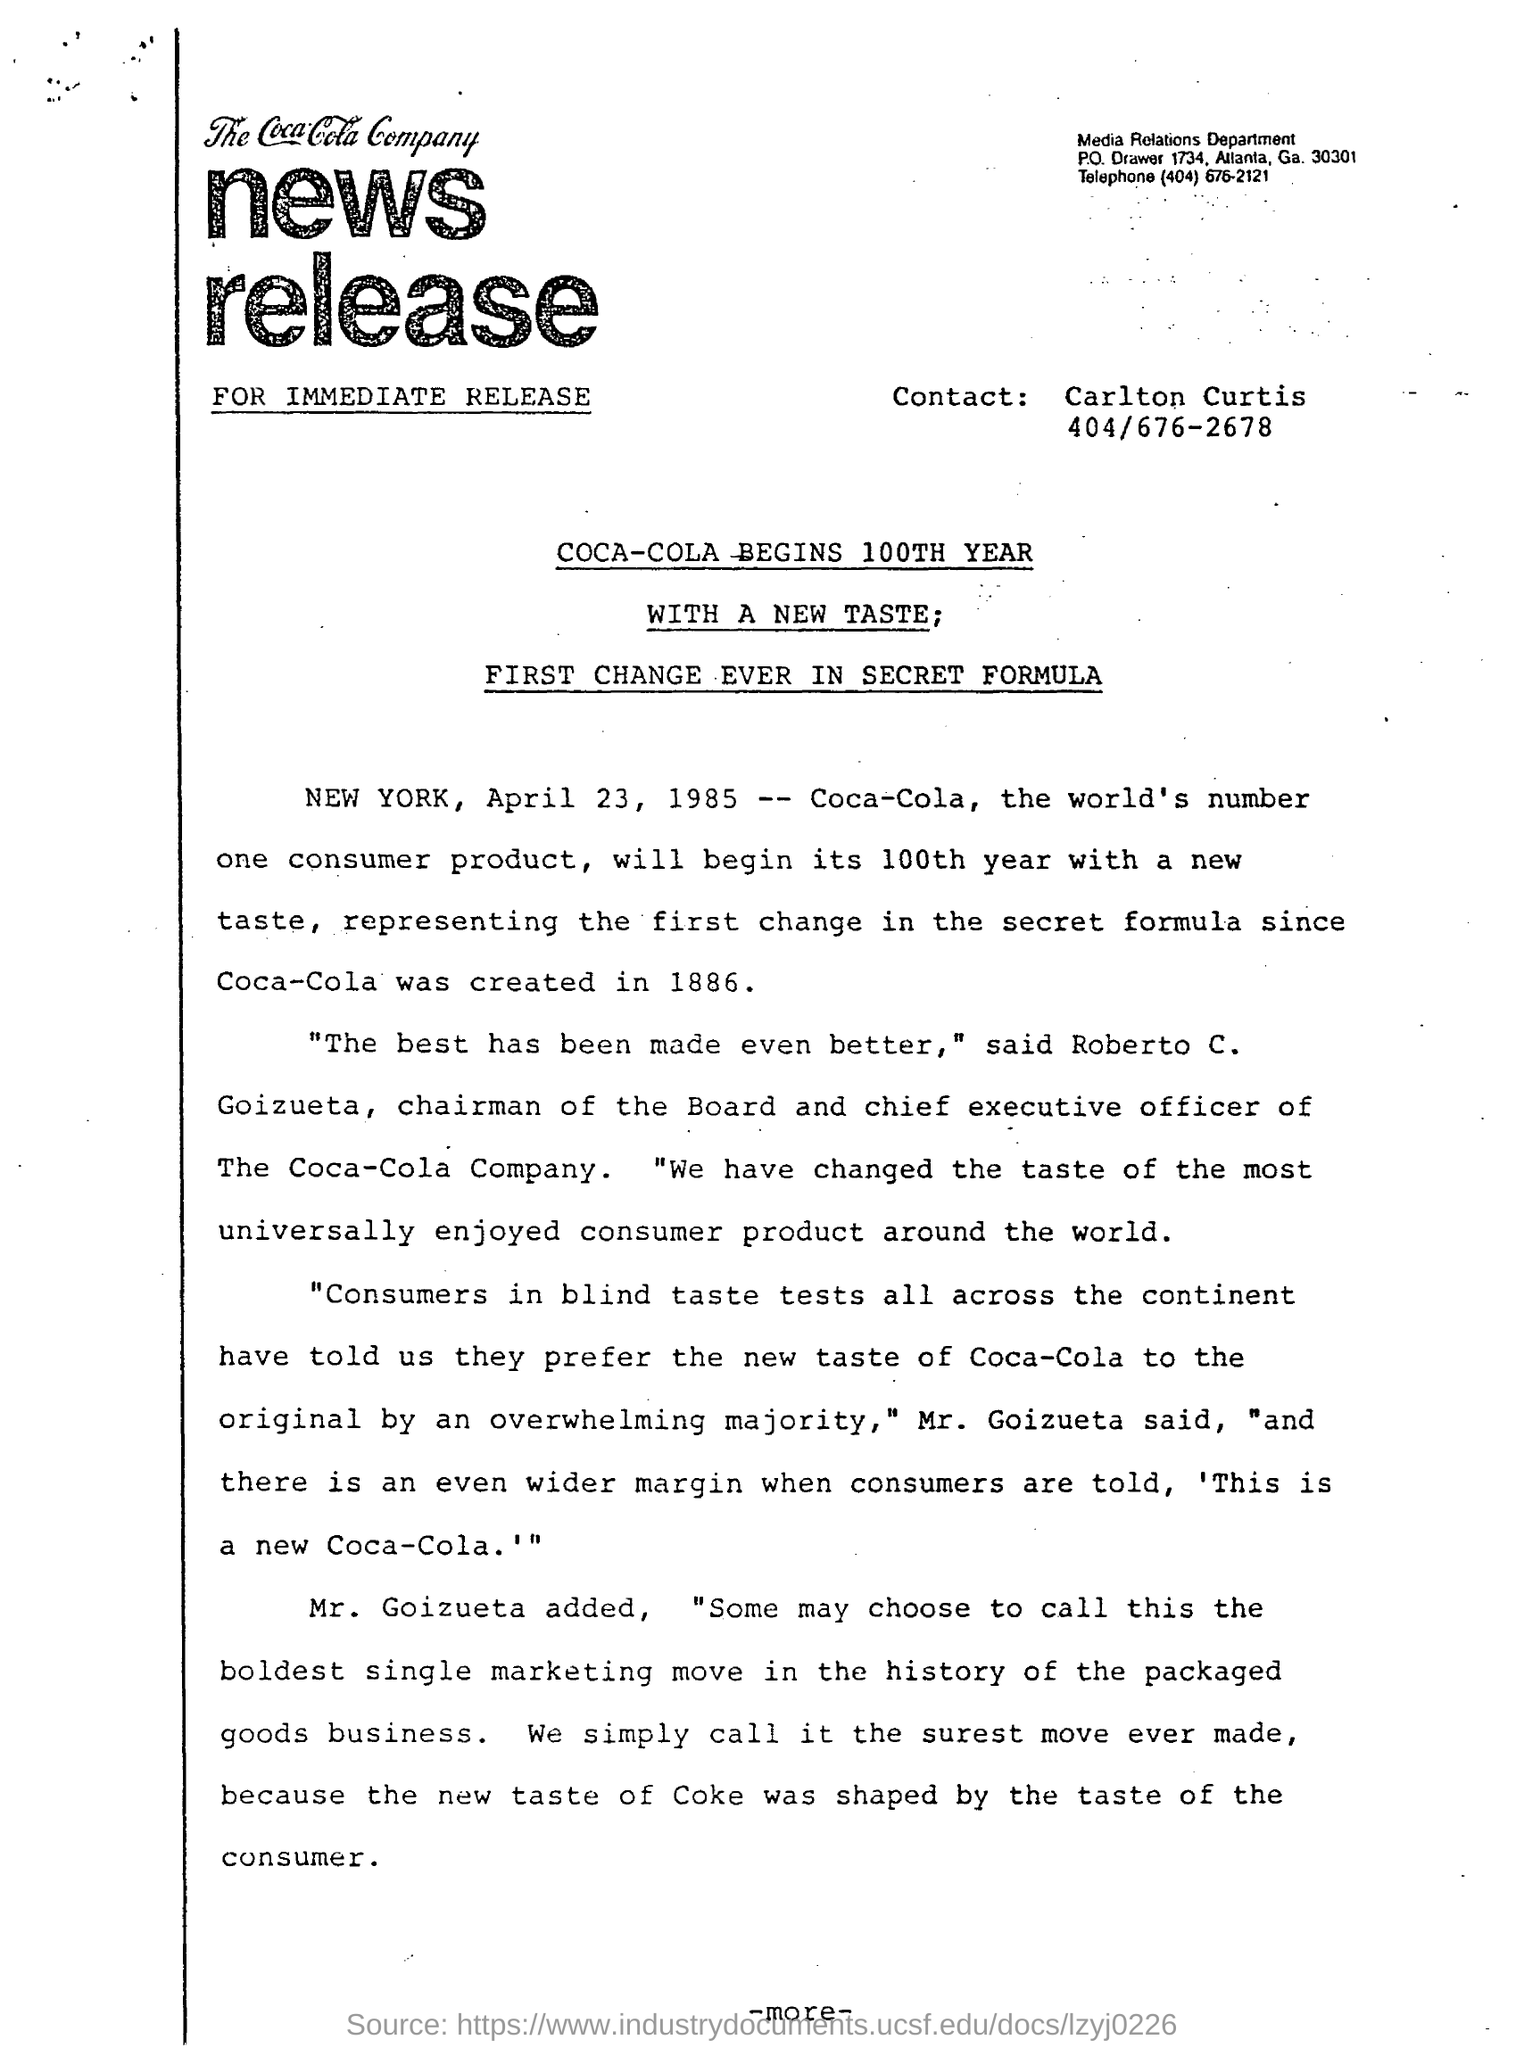What is the name of the person mentioned to Contact?
Provide a succinct answer. Carlton. Which year is COCA-COLA beginning with a new taste?
Provide a succinct answer. 100th year. What is the date mentioned?
Make the answer very short. April 23, 1985. Who said, "The best has been made even better"?
Provide a short and direct response. Roberto C. Goizueta, chairman of the Board and Chief executive officer of The Coca-Cola Company. 